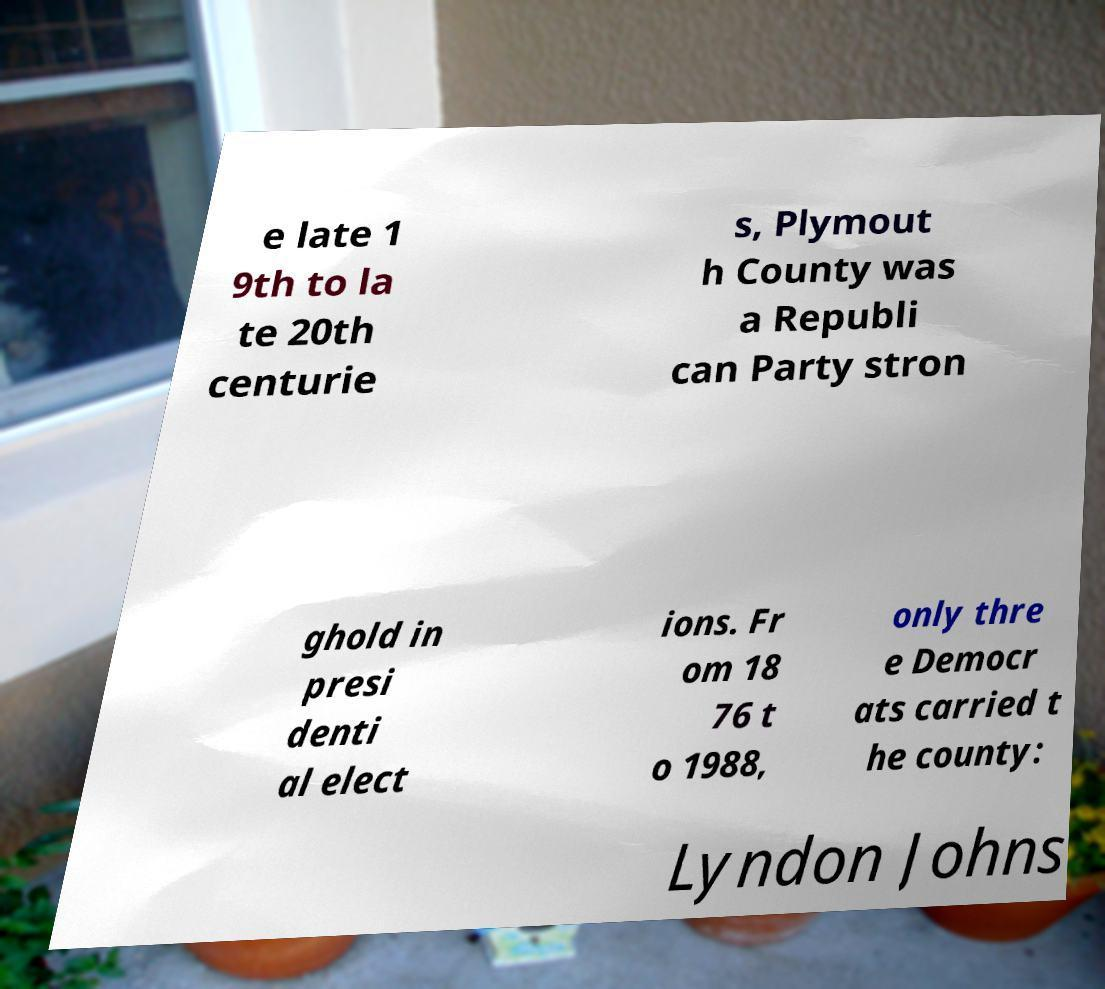There's text embedded in this image that I need extracted. Can you transcribe it verbatim? e late 1 9th to la te 20th centurie s, Plymout h County was a Republi can Party stron ghold in presi denti al elect ions. Fr om 18 76 t o 1988, only thre e Democr ats carried t he county: Lyndon Johns 